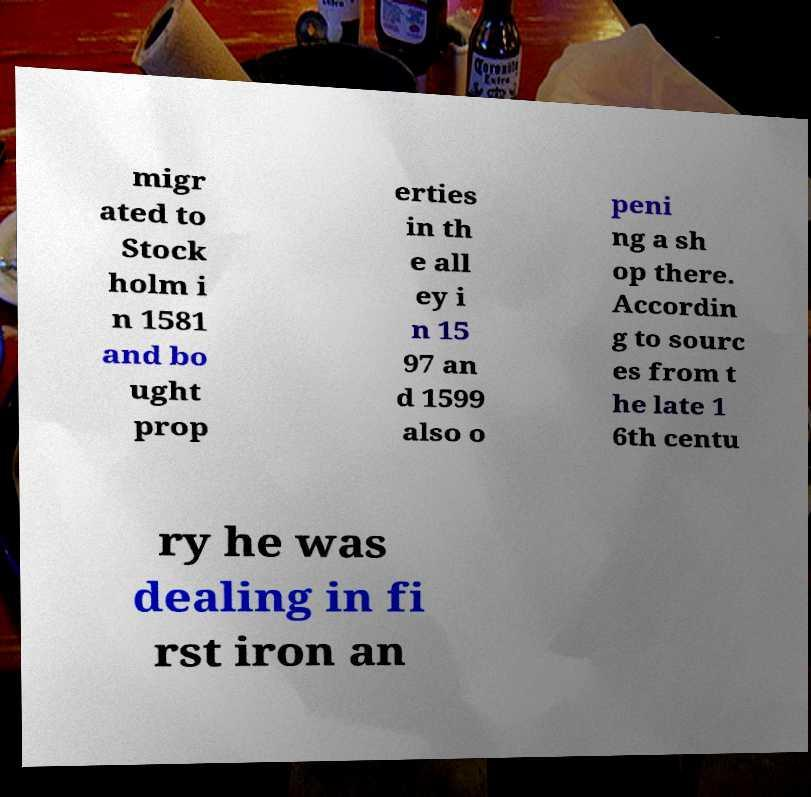Can you read and provide the text displayed in the image?This photo seems to have some interesting text. Can you extract and type it out for me? migr ated to Stock holm i n 1581 and bo ught prop erties in th e all ey i n 15 97 an d 1599 also o peni ng a sh op there. Accordin g to sourc es from t he late 1 6th centu ry he was dealing in fi rst iron an 